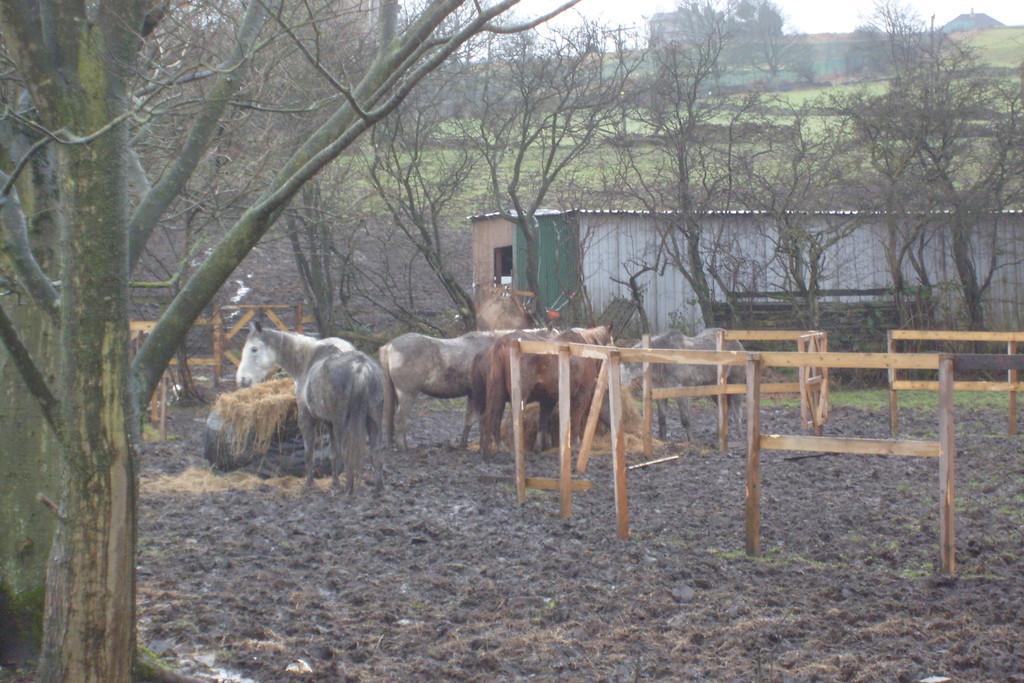How would you summarize this image in a sentence or two? In the center of the image there are horses and we can see a fence. In the background there is a shed and we can see trees. There is sky. 